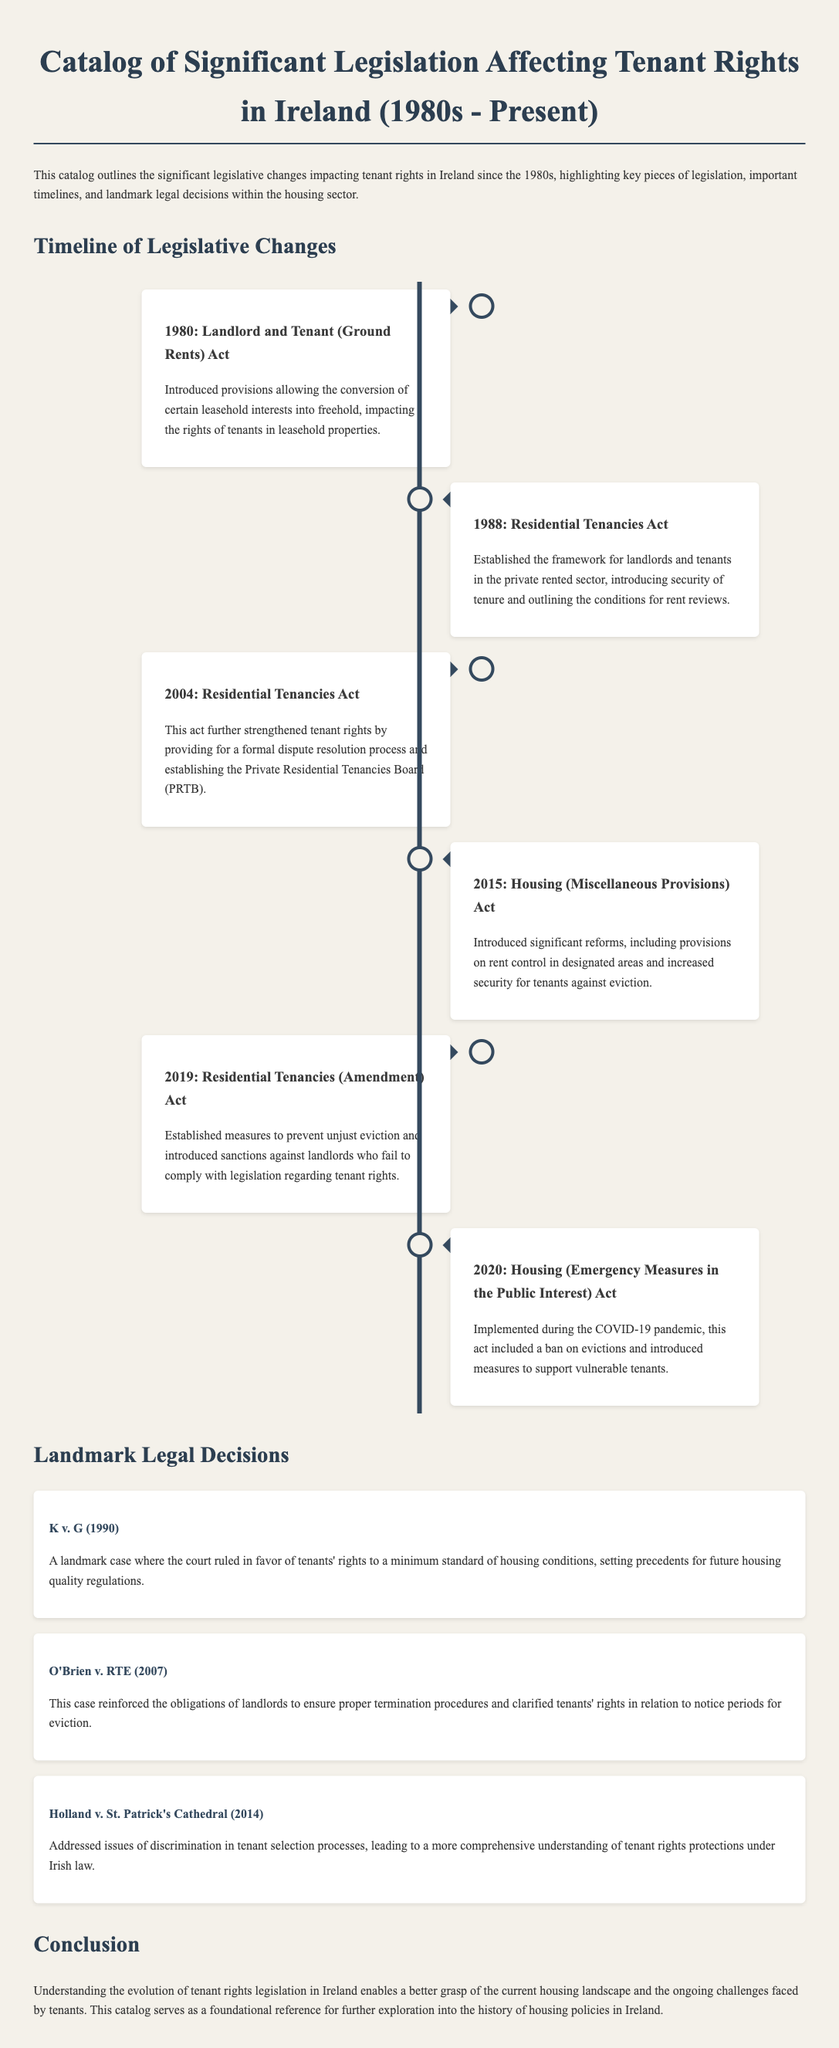What year was the Landlord and Tenant (Ground Rents) Act introduced? The document states that the Landlord and Tenant (Ground Rents) Act was introduced in 1980.
Answer: 1980 What is the name of the board established by the 2004 Residential Tenancies Act? The 2004 Residential Tenancies Act established the Private Residential Tenancies Board (PRTB).
Answer: Private Residential Tenancies Board (PRTB) Which act was implemented during the COVID-19 pandemic? According to the document, the Housing (Emergency Measures in the Public Interest) Act was implemented during the COVID-19 pandemic.
Answer: Housing (Emergency Measures in the Public Interest) Act What was a significant reform introduced by the 2015 Housing (Miscellaneous Provisions) Act? The 2015 Housing (Miscellaneous Provisions) Act introduced provisions on rent control in designated areas.
Answer: Rent control in designated areas Which landmark case highlighted the right to a minimum standard of housing conditions? The K v. G case from 1990 highlighted the right to a minimum standard of housing conditions.
Answer: K v. G How many significant legislative changes are listed in the timeline? The timeline in the document lists six significant legislative changes.
Answer: Six Which act followed the 1988 Residential Tenancies Act in the document? The act that followed the 1988 Residential Tenancies Act is the 2004 Residential Tenancies Act.
Answer: 2004 Residential Tenancies Act What is the primary focus of this catalog? The primary focus of this catalog is outlining significant legislative changes impacting tenant rights in Ireland since the 1980s.
Answer: Tenant rights What is the purpose of the case studies included in the document? The case studies serve to illustrate landmark legal decisions affecting tenant rights in housing.
Answer: Illustrate landmark legal decisions 